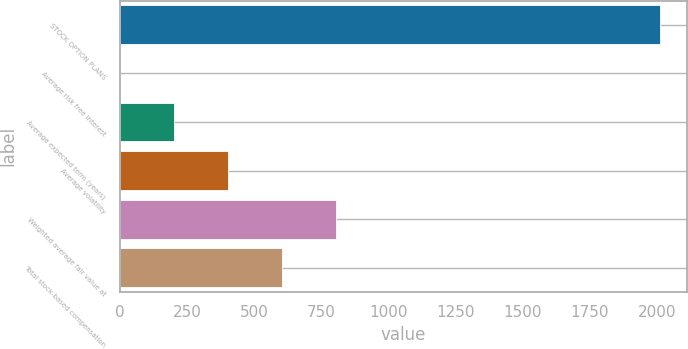<chart> <loc_0><loc_0><loc_500><loc_500><bar_chart><fcel>STOCK OPTION PLANS<fcel>Average risk free interest<fcel>Average expected term (years)<fcel>Average volatility<fcel>Weighted average fair value at<fcel>Total stock-based compensation<nl><fcel>2010<fcel>2.24<fcel>203.02<fcel>403.8<fcel>805.36<fcel>604.58<nl></chart> 